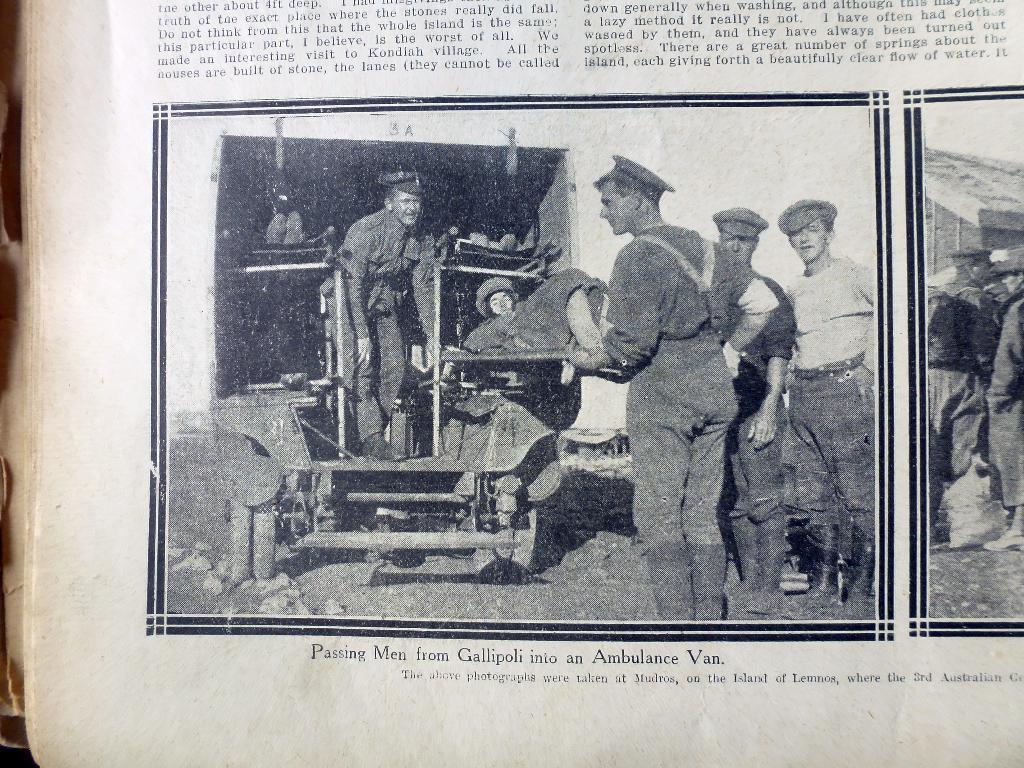Describe this image in one or two sentences. In this picture we can observe a photo in the paper. This is a black and white image. We can observe some people standing and there is a woman laying on the stretcher. We can observe some sentences on this paper. The paper is in white color. 